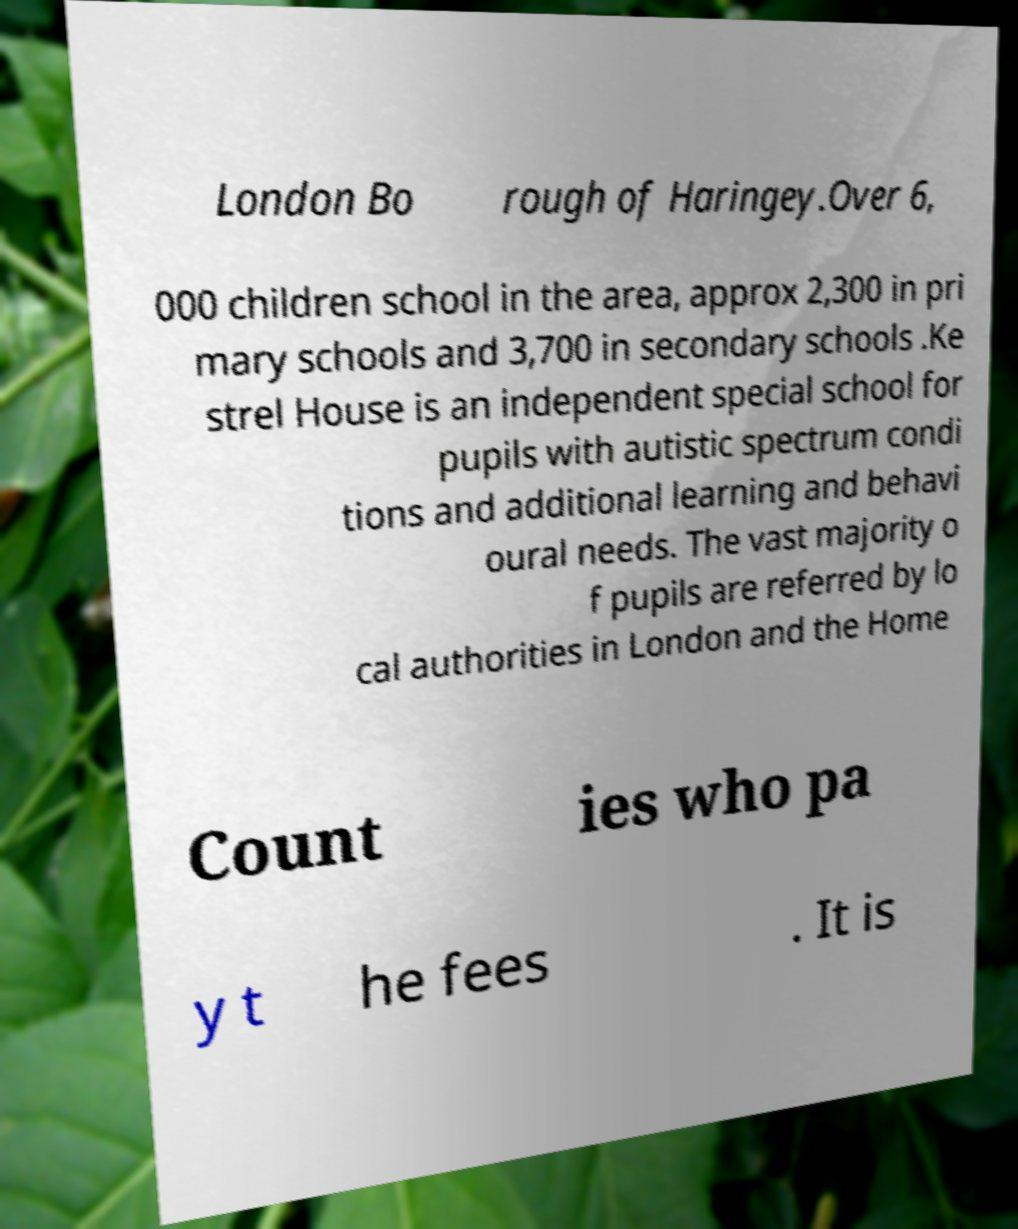Please read and relay the text visible in this image. What does it say? London Bo rough of Haringey.Over 6, 000 children school in the area, approx 2,300 in pri mary schools and 3,700 in secondary schools .Ke strel House is an independent special school for pupils with autistic spectrum condi tions and additional learning and behavi oural needs. The vast majority o f pupils are referred by lo cal authorities in London and the Home Count ies who pa y t he fees . It is 